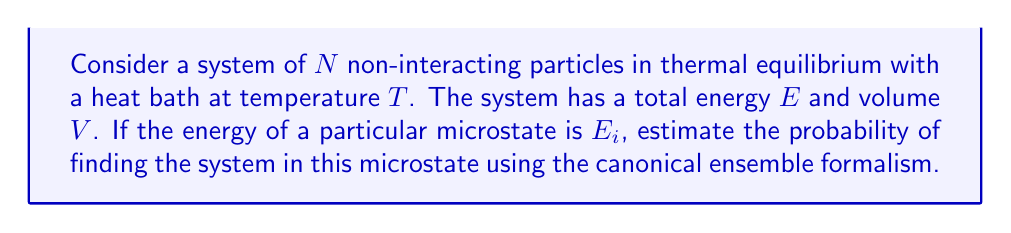Show me your answer to this math problem. To solve this problem, we'll follow these steps:

1) In the canonical ensemble, the probability of a microstate $i$ with energy $E_i$ is given by:

   $$P_i = \frac{e^{-\beta E_i}}{Z}$$

   where $\beta = \frac{1}{k_B T}$, $k_B$ is Boltzmann's constant, and $Z$ is the partition function.

2) The partition function $Z$ is defined as:

   $$Z = \sum_j e^{-\beta E_j}$$

   where the sum is over all possible microstates $j$.

3) We don't have enough information to calculate the exact value of $Z$, but we can express our answer in terms of $Z$.

4) Given the energy of the particular microstate $E_i$, we can calculate the numerator:

   $$e^{-\beta E_i} = e^{-E_i / (k_B T)}$$

5) Therefore, the probability of finding the system in the microstate with energy $E_i$ is:

   $$P_i = \frac{e^{-E_i / (k_B T)}}{Z}$$

This expression gives us the estimated probability of the particular microstate in the canonical ensemble.
Answer: $P_i = \frac{e^{-E_i / (k_B T)}}{Z}$ 